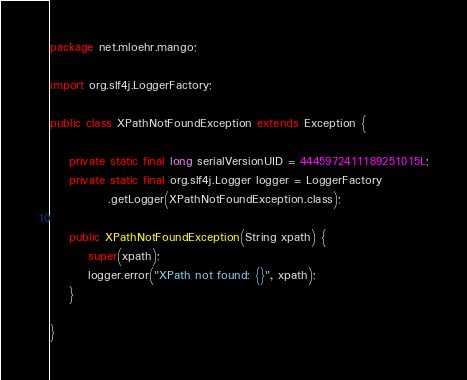<code> <loc_0><loc_0><loc_500><loc_500><_Java_>package net.mloehr.mango;

import org.slf4j.LoggerFactory;

public class XPathNotFoundException extends Exception {

    private static final long serialVersionUID = 4445972411189251015L;
    private static final org.slf4j.Logger logger = LoggerFactory
            .getLogger(XPathNotFoundException.class);

    public XPathNotFoundException(String xpath) {
        super(xpath);
        logger.error("XPath not found: {}", xpath);
    }

}
</code> 